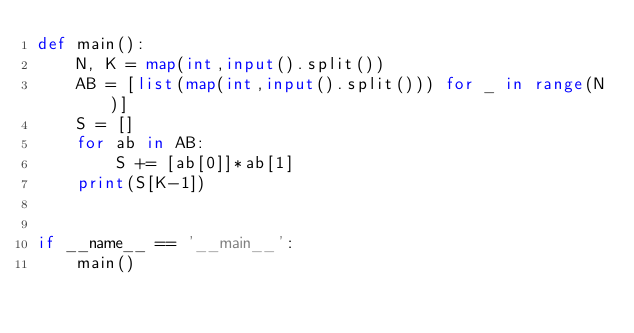<code> <loc_0><loc_0><loc_500><loc_500><_Python_>def main():
    N, K = map(int,input().split())
    AB = [list(map(int,input().split())) for _ in range(N)]
    S = []
    for ab in AB:
        S += [ab[0]]*ab[1]
    print(S[K-1])
            

if __name__ == '__main__':
    main()
</code> 